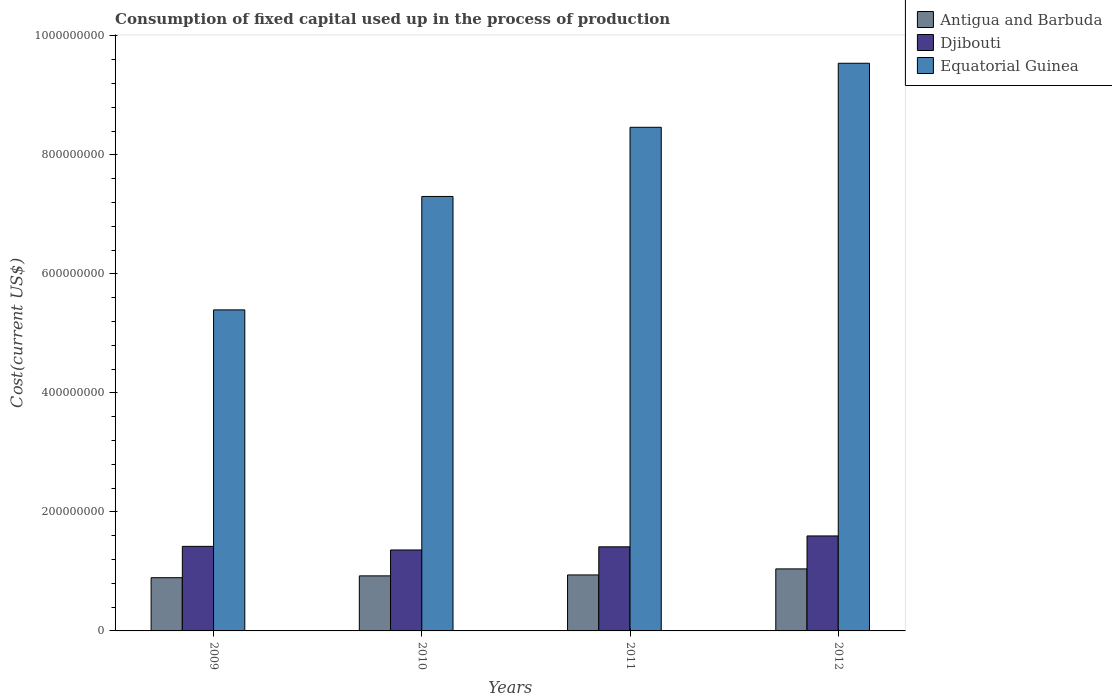How many different coloured bars are there?
Ensure brevity in your answer.  3. How many groups of bars are there?
Offer a terse response. 4. Are the number of bars per tick equal to the number of legend labels?
Keep it short and to the point. Yes. How many bars are there on the 2nd tick from the right?
Your response must be concise. 3. In how many cases, is the number of bars for a given year not equal to the number of legend labels?
Offer a very short reply. 0. What is the amount consumed in the process of production in Djibouti in 2009?
Give a very brief answer. 1.42e+08. Across all years, what is the maximum amount consumed in the process of production in Antigua and Barbuda?
Give a very brief answer. 1.04e+08. Across all years, what is the minimum amount consumed in the process of production in Antigua and Barbuda?
Your answer should be compact. 8.94e+07. In which year was the amount consumed in the process of production in Djibouti maximum?
Provide a short and direct response. 2012. In which year was the amount consumed in the process of production in Antigua and Barbuda minimum?
Your answer should be very brief. 2009. What is the total amount consumed in the process of production in Equatorial Guinea in the graph?
Give a very brief answer. 3.07e+09. What is the difference between the amount consumed in the process of production in Equatorial Guinea in 2010 and that in 2012?
Provide a succinct answer. -2.24e+08. What is the difference between the amount consumed in the process of production in Equatorial Guinea in 2010 and the amount consumed in the process of production in Antigua and Barbuda in 2012?
Ensure brevity in your answer.  6.26e+08. What is the average amount consumed in the process of production in Antigua and Barbuda per year?
Make the answer very short. 9.51e+07. In the year 2010, what is the difference between the amount consumed in the process of production in Djibouti and amount consumed in the process of production in Equatorial Guinea?
Keep it short and to the point. -5.94e+08. What is the ratio of the amount consumed in the process of production in Antigua and Barbuda in 2009 to that in 2011?
Offer a very short reply. 0.95. What is the difference between the highest and the second highest amount consumed in the process of production in Equatorial Guinea?
Ensure brevity in your answer.  1.08e+08. What is the difference between the highest and the lowest amount consumed in the process of production in Djibouti?
Offer a terse response. 2.36e+07. In how many years, is the amount consumed in the process of production in Equatorial Guinea greater than the average amount consumed in the process of production in Equatorial Guinea taken over all years?
Offer a very short reply. 2. Is the sum of the amount consumed in the process of production in Antigua and Barbuda in 2009 and 2011 greater than the maximum amount consumed in the process of production in Equatorial Guinea across all years?
Your answer should be compact. No. What does the 1st bar from the left in 2010 represents?
Your answer should be compact. Antigua and Barbuda. What does the 2nd bar from the right in 2011 represents?
Your response must be concise. Djibouti. Are the values on the major ticks of Y-axis written in scientific E-notation?
Your answer should be very brief. No. Does the graph contain any zero values?
Offer a very short reply. No. Where does the legend appear in the graph?
Provide a succinct answer. Top right. What is the title of the graph?
Make the answer very short. Consumption of fixed capital used up in the process of production. What is the label or title of the Y-axis?
Ensure brevity in your answer.  Cost(current US$). What is the Cost(current US$) in Antigua and Barbuda in 2009?
Your response must be concise. 8.94e+07. What is the Cost(current US$) of Djibouti in 2009?
Your answer should be compact. 1.42e+08. What is the Cost(current US$) in Equatorial Guinea in 2009?
Provide a succinct answer. 5.39e+08. What is the Cost(current US$) in Antigua and Barbuda in 2010?
Ensure brevity in your answer.  9.25e+07. What is the Cost(current US$) in Djibouti in 2010?
Keep it short and to the point. 1.36e+08. What is the Cost(current US$) of Equatorial Guinea in 2010?
Keep it short and to the point. 7.30e+08. What is the Cost(current US$) of Antigua and Barbuda in 2011?
Your response must be concise. 9.41e+07. What is the Cost(current US$) of Djibouti in 2011?
Offer a terse response. 1.41e+08. What is the Cost(current US$) of Equatorial Guinea in 2011?
Give a very brief answer. 8.46e+08. What is the Cost(current US$) of Antigua and Barbuda in 2012?
Your response must be concise. 1.04e+08. What is the Cost(current US$) in Djibouti in 2012?
Offer a terse response. 1.60e+08. What is the Cost(current US$) of Equatorial Guinea in 2012?
Offer a terse response. 9.54e+08. Across all years, what is the maximum Cost(current US$) in Antigua and Barbuda?
Give a very brief answer. 1.04e+08. Across all years, what is the maximum Cost(current US$) of Djibouti?
Provide a short and direct response. 1.60e+08. Across all years, what is the maximum Cost(current US$) of Equatorial Guinea?
Ensure brevity in your answer.  9.54e+08. Across all years, what is the minimum Cost(current US$) in Antigua and Barbuda?
Provide a succinct answer. 8.94e+07. Across all years, what is the minimum Cost(current US$) of Djibouti?
Provide a short and direct response. 1.36e+08. Across all years, what is the minimum Cost(current US$) of Equatorial Guinea?
Make the answer very short. 5.39e+08. What is the total Cost(current US$) in Antigua and Barbuda in the graph?
Your response must be concise. 3.80e+08. What is the total Cost(current US$) of Djibouti in the graph?
Your answer should be very brief. 5.79e+08. What is the total Cost(current US$) of Equatorial Guinea in the graph?
Keep it short and to the point. 3.07e+09. What is the difference between the Cost(current US$) of Antigua and Barbuda in 2009 and that in 2010?
Make the answer very short. -3.07e+06. What is the difference between the Cost(current US$) in Djibouti in 2009 and that in 2010?
Provide a succinct answer. 6.06e+06. What is the difference between the Cost(current US$) in Equatorial Guinea in 2009 and that in 2010?
Make the answer very short. -1.91e+08. What is the difference between the Cost(current US$) of Antigua and Barbuda in 2009 and that in 2011?
Ensure brevity in your answer.  -4.65e+06. What is the difference between the Cost(current US$) in Djibouti in 2009 and that in 2011?
Your answer should be very brief. 7.59e+05. What is the difference between the Cost(current US$) in Equatorial Guinea in 2009 and that in 2011?
Ensure brevity in your answer.  -3.07e+08. What is the difference between the Cost(current US$) in Antigua and Barbuda in 2009 and that in 2012?
Give a very brief answer. -1.48e+07. What is the difference between the Cost(current US$) in Djibouti in 2009 and that in 2012?
Offer a terse response. -1.75e+07. What is the difference between the Cost(current US$) of Equatorial Guinea in 2009 and that in 2012?
Provide a short and direct response. -4.14e+08. What is the difference between the Cost(current US$) of Antigua and Barbuda in 2010 and that in 2011?
Give a very brief answer. -1.57e+06. What is the difference between the Cost(current US$) of Djibouti in 2010 and that in 2011?
Your answer should be very brief. -5.30e+06. What is the difference between the Cost(current US$) in Equatorial Guinea in 2010 and that in 2011?
Your answer should be very brief. -1.16e+08. What is the difference between the Cost(current US$) in Antigua and Barbuda in 2010 and that in 2012?
Offer a terse response. -1.17e+07. What is the difference between the Cost(current US$) in Djibouti in 2010 and that in 2012?
Your answer should be very brief. -2.36e+07. What is the difference between the Cost(current US$) of Equatorial Guinea in 2010 and that in 2012?
Offer a very short reply. -2.24e+08. What is the difference between the Cost(current US$) of Antigua and Barbuda in 2011 and that in 2012?
Provide a short and direct response. -1.01e+07. What is the difference between the Cost(current US$) of Djibouti in 2011 and that in 2012?
Your answer should be compact. -1.83e+07. What is the difference between the Cost(current US$) of Equatorial Guinea in 2011 and that in 2012?
Provide a short and direct response. -1.08e+08. What is the difference between the Cost(current US$) in Antigua and Barbuda in 2009 and the Cost(current US$) in Djibouti in 2010?
Give a very brief answer. -4.66e+07. What is the difference between the Cost(current US$) in Antigua and Barbuda in 2009 and the Cost(current US$) in Equatorial Guinea in 2010?
Your answer should be very brief. -6.41e+08. What is the difference between the Cost(current US$) in Djibouti in 2009 and the Cost(current US$) in Equatorial Guinea in 2010?
Keep it short and to the point. -5.88e+08. What is the difference between the Cost(current US$) in Antigua and Barbuda in 2009 and the Cost(current US$) in Djibouti in 2011?
Provide a short and direct response. -5.19e+07. What is the difference between the Cost(current US$) of Antigua and Barbuda in 2009 and the Cost(current US$) of Equatorial Guinea in 2011?
Ensure brevity in your answer.  -7.57e+08. What is the difference between the Cost(current US$) of Djibouti in 2009 and the Cost(current US$) of Equatorial Guinea in 2011?
Give a very brief answer. -7.04e+08. What is the difference between the Cost(current US$) of Antigua and Barbuda in 2009 and the Cost(current US$) of Djibouti in 2012?
Make the answer very short. -7.02e+07. What is the difference between the Cost(current US$) of Antigua and Barbuda in 2009 and the Cost(current US$) of Equatorial Guinea in 2012?
Give a very brief answer. -8.64e+08. What is the difference between the Cost(current US$) in Djibouti in 2009 and the Cost(current US$) in Equatorial Guinea in 2012?
Provide a succinct answer. -8.12e+08. What is the difference between the Cost(current US$) of Antigua and Barbuda in 2010 and the Cost(current US$) of Djibouti in 2011?
Your answer should be very brief. -4.88e+07. What is the difference between the Cost(current US$) in Antigua and Barbuda in 2010 and the Cost(current US$) in Equatorial Guinea in 2011?
Give a very brief answer. -7.54e+08. What is the difference between the Cost(current US$) in Djibouti in 2010 and the Cost(current US$) in Equatorial Guinea in 2011?
Your answer should be very brief. -7.10e+08. What is the difference between the Cost(current US$) of Antigua and Barbuda in 2010 and the Cost(current US$) of Djibouti in 2012?
Provide a succinct answer. -6.71e+07. What is the difference between the Cost(current US$) in Antigua and Barbuda in 2010 and the Cost(current US$) in Equatorial Guinea in 2012?
Give a very brief answer. -8.61e+08. What is the difference between the Cost(current US$) of Djibouti in 2010 and the Cost(current US$) of Equatorial Guinea in 2012?
Keep it short and to the point. -8.18e+08. What is the difference between the Cost(current US$) in Antigua and Barbuda in 2011 and the Cost(current US$) in Djibouti in 2012?
Provide a short and direct response. -6.55e+07. What is the difference between the Cost(current US$) in Antigua and Barbuda in 2011 and the Cost(current US$) in Equatorial Guinea in 2012?
Make the answer very short. -8.60e+08. What is the difference between the Cost(current US$) in Djibouti in 2011 and the Cost(current US$) in Equatorial Guinea in 2012?
Your response must be concise. -8.13e+08. What is the average Cost(current US$) in Antigua and Barbuda per year?
Ensure brevity in your answer.  9.51e+07. What is the average Cost(current US$) in Djibouti per year?
Your answer should be compact. 1.45e+08. What is the average Cost(current US$) of Equatorial Guinea per year?
Ensure brevity in your answer.  7.67e+08. In the year 2009, what is the difference between the Cost(current US$) in Antigua and Barbuda and Cost(current US$) in Djibouti?
Your answer should be compact. -5.27e+07. In the year 2009, what is the difference between the Cost(current US$) in Antigua and Barbuda and Cost(current US$) in Equatorial Guinea?
Your answer should be very brief. -4.50e+08. In the year 2009, what is the difference between the Cost(current US$) in Djibouti and Cost(current US$) in Equatorial Guinea?
Offer a terse response. -3.97e+08. In the year 2010, what is the difference between the Cost(current US$) of Antigua and Barbuda and Cost(current US$) of Djibouti?
Make the answer very short. -4.35e+07. In the year 2010, what is the difference between the Cost(current US$) of Antigua and Barbuda and Cost(current US$) of Equatorial Guinea?
Your answer should be very brief. -6.38e+08. In the year 2010, what is the difference between the Cost(current US$) in Djibouti and Cost(current US$) in Equatorial Guinea?
Ensure brevity in your answer.  -5.94e+08. In the year 2011, what is the difference between the Cost(current US$) in Antigua and Barbuda and Cost(current US$) in Djibouti?
Provide a succinct answer. -4.72e+07. In the year 2011, what is the difference between the Cost(current US$) of Antigua and Barbuda and Cost(current US$) of Equatorial Guinea?
Keep it short and to the point. -7.52e+08. In the year 2011, what is the difference between the Cost(current US$) in Djibouti and Cost(current US$) in Equatorial Guinea?
Offer a terse response. -7.05e+08. In the year 2012, what is the difference between the Cost(current US$) of Antigua and Barbuda and Cost(current US$) of Djibouti?
Keep it short and to the point. -5.54e+07. In the year 2012, what is the difference between the Cost(current US$) of Antigua and Barbuda and Cost(current US$) of Equatorial Guinea?
Offer a terse response. -8.50e+08. In the year 2012, what is the difference between the Cost(current US$) of Djibouti and Cost(current US$) of Equatorial Guinea?
Keep it short and to the point. -7.94e+08. What is the ratio of the Cost(current US$) of Antigua and Barbuda in 2009 to that in 2010?
Give a very brief answer. 0.97. What is the ratio of the Cost(current US$) in Djibouti in 2009 to that in 2010?
Your response must be concise. 1.04. What is the ratio of the Cost(current US$) of Equatorial Guinea in 2009 to that in 2010?
Provide a succinct answer. 0.74. What is the ratio of the Cost(current US$) in Antigua and Barbuda in 2009 to that in 2011?
Keep it short and to the point. 0.95. What is the ratio of the Cost(current US$) of Djibouti in 2009 to that in 2011?
Your answer should be compact. 1.01. What is the ratio of the Cost(current US$) of Equatorial Guinea in 2009 to that in 2011?
Give a very brief answer. 0.64. What is the ratio of the Cost(current US$) in Antigua and Barbuda in 2009 to that in 2012?
Offer a terse response. 0.86. What is the ratio of the Cost(current US$) in Djibouti in 2009 to that in 2012?
Keep it short and to the point. 0.89. What is the ratio of the Cost(current US$) of Equatorial Guinea in 2009 to that in 2012?
Ensure brevity in your answer.  0.57. What is the ratio of the Cost(current US$) in Antigua and Barbuda in 2010 to that in 2011?
Offer a very short reply. 0.98. What is the ratio of the Cost(current US$) in Djibouti in 2010 to that in 2011?
Provide a short and direct response. 0.96. What is the ratio of the Cost(current US$) of Equatorial Guinea in 2010 to that in 2011?
Give a very brief answer. 0.86. What is the ratio of the Cost(current US$) of Antigua and Barbuda in 2010 to that in 2012?
Give a very brief answer. 0.89. What is the ratio of the Cost(current US$) of Djibouti in 2010 to that in 2012?
Offer a very short reply. 0.85. What is the ratio of the Cost(current US$) of Equatorial Guinea in 2010 to that in 2012?
Your answer should be compact. 0.77. What is the ratio of the Cost(current US$) in Antigua and Barbuda in 2011 to that in 2012?
Ensure brevity in your answer.  0.9. What is the ratio of the Cost(current US$) in Djibouti in 2011 to that in 2012?
Your response must be concise. 0.89. What is the ratio of the Cost(current US$) in Equatorial Guinea in 2011 to that in 2012?
Make the answer very short. 0.89. What is the difference between the highest and the second highest Cost(current US$) in Antigua and Barbuda?
Make the answer very short. 1.01e+07. What is the difference between the highest and the second highest Cost(current US$) of Djibouti?
Make the answer very short. 1.75e+07. What is the difference between the highest and the second highest Cost(current US$) of Equatorial Guinea?
Keep it short and to the point. 1.08e+08. What is the difference between the highest and the lowest Cost(current US$) in Antigua and Barbuda?
Your answer should be compact. 1.48e+07. What is the difference between the highest and the lowest Cost(current US$) in Djibouti?
Ensure brevity in your answer.  2.36e+07. What is the difference between the highest and the lowest Cost(current US$) of Equatorial Guinea?
Ensure brevity in your answer.  4.14e+08. 